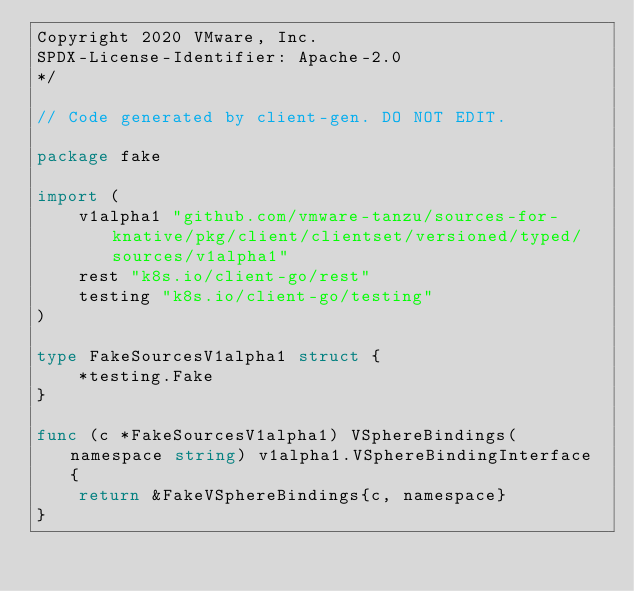Convert code to text. <code><loc_0><loc_0><loc_500><loc_500><_Go_>Copyright 2020 VMware, Inc.
SPDX-License-Identifier: Apache-2.0
*/

// Code generated by client-gen. DO NOT EDIT.

package fake

import (
	v1alpha1 "github.com/vmware-tanzu/sources-for-knative/pkg/client/clientset/versioned/typed/sources/v1alpha1"
	rest "k8s.io/client-go/rest"
	testing "k8s.io/client-go/testing"
)

type FakeSourcesV1alpha1 struct {
	*testing.Fake
}

func (c *FakeSourcesV1alpha1) VSphereBindings(namespace string) v1alpha1.VSphereBindingInterface {
	return &FakeVSphereBindings{c, namespace}
}
</code> 